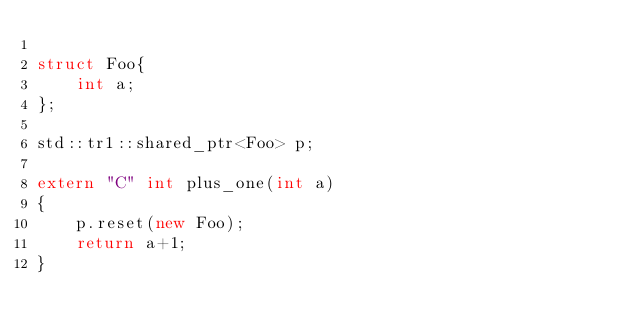Convert code to text. <code><loc_0><loc_0><loc_500><loc_500><_C++_>
struct Foo{
    int a;
};

std::tr1::shared_ptr<Foo> p;

extern "C" int plus_one(int a)
{
    p.reset(new Foo);
    return a+1;
}
</code> 